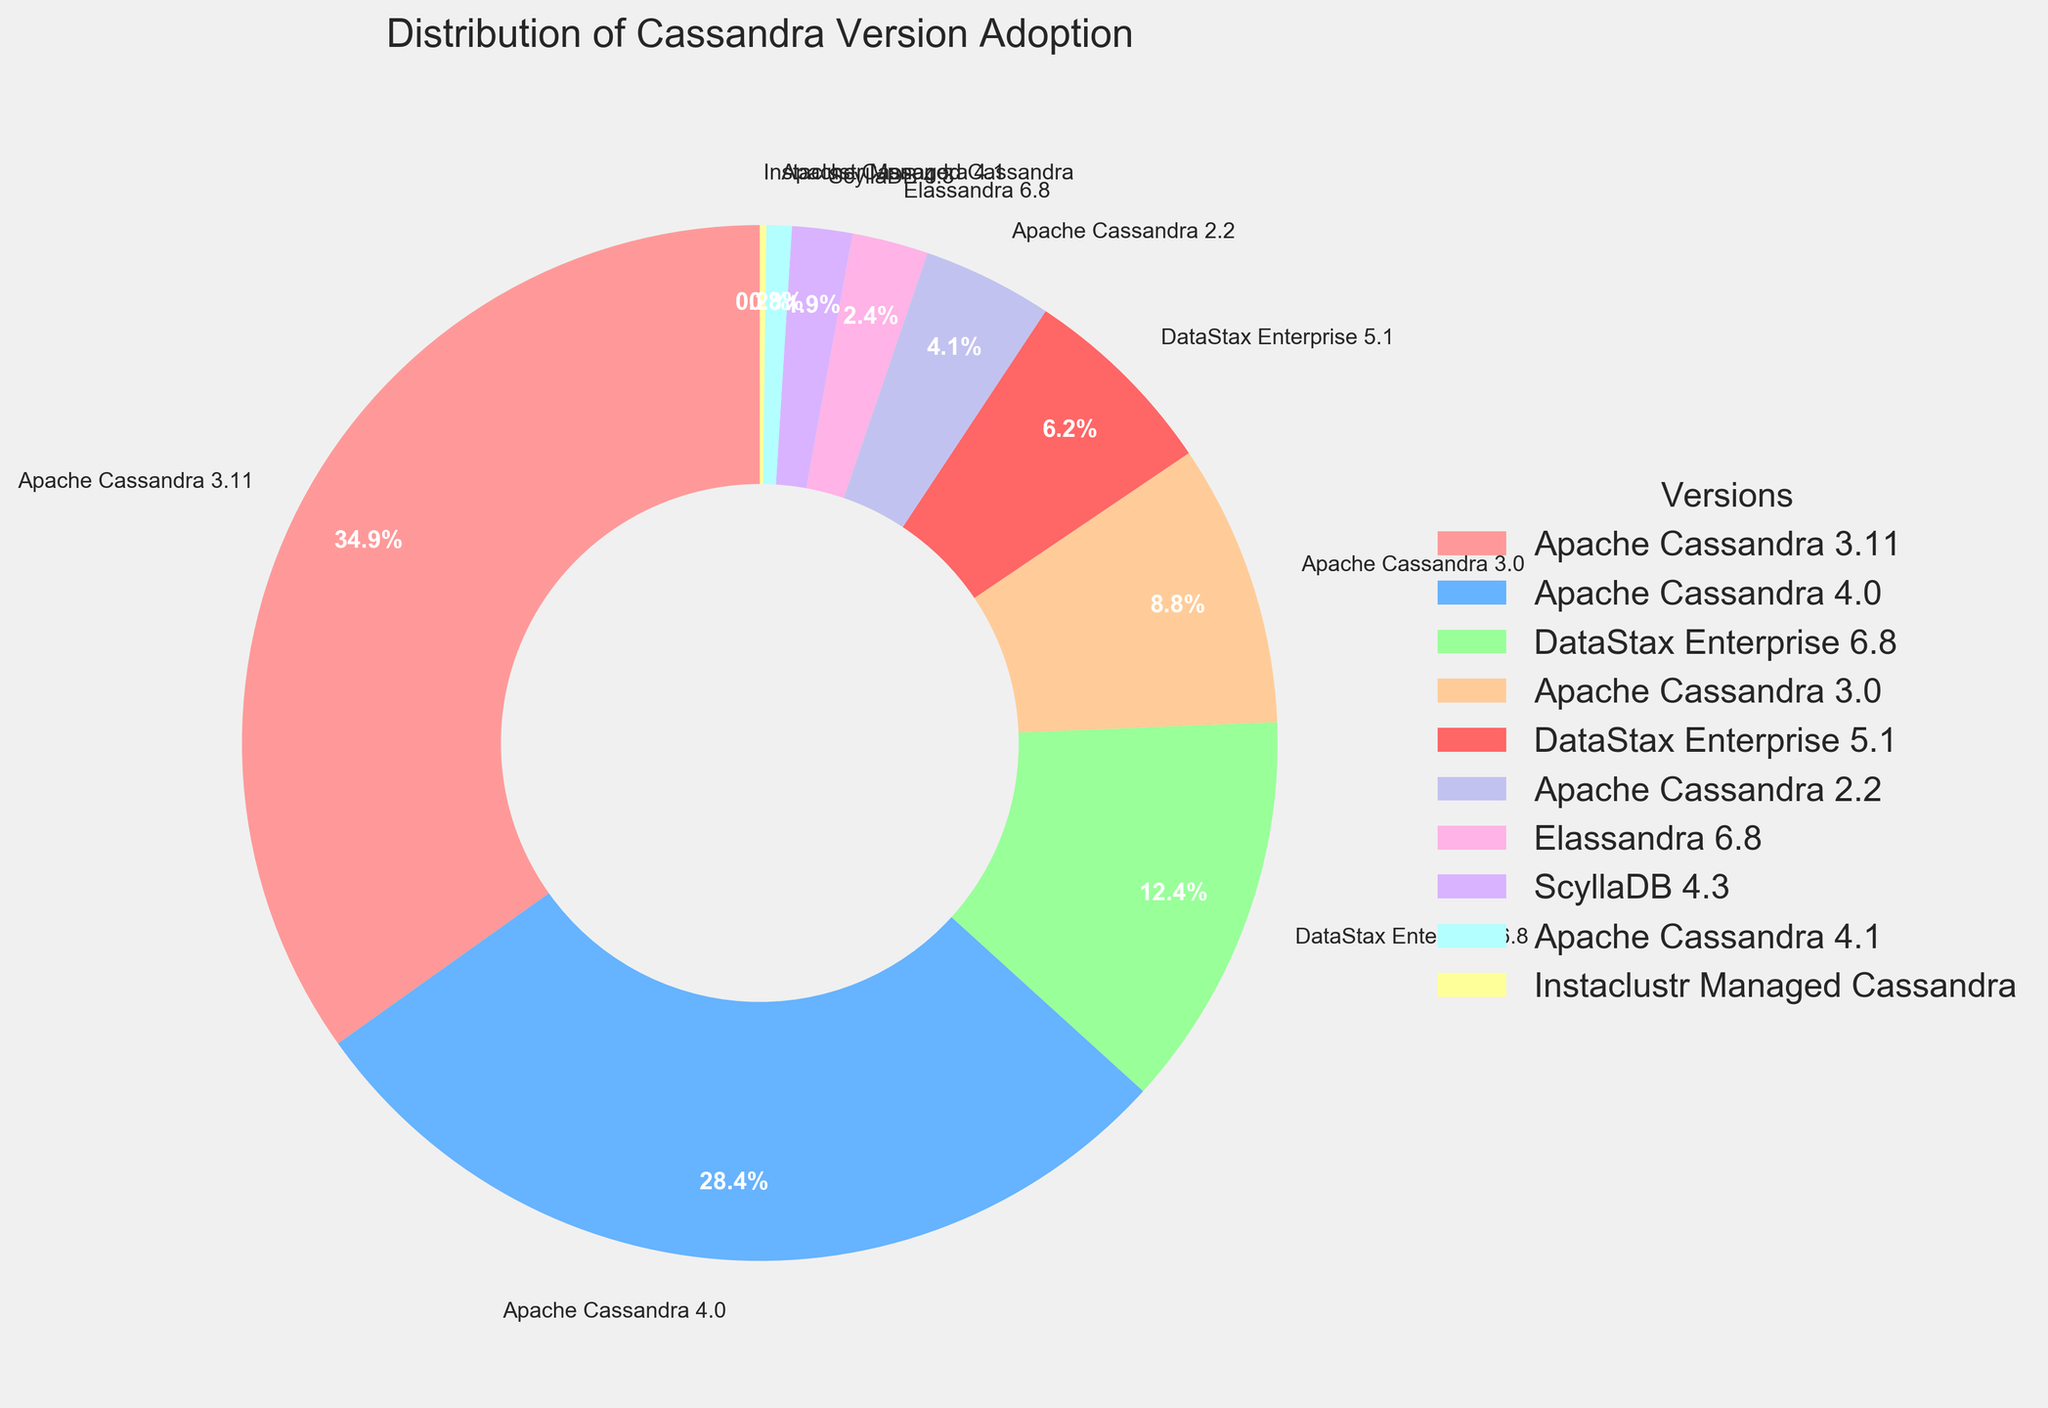What is the most adopted Cassandra version among organizations? The most adopted version can be identified by finding the version with the highest percentage. Apache Cassandra 3.11 has the highest percentage at 35.2%.
Answer: Apache Cassandra 3.11 Which version has a higher adoption rate: Apache Cassandra 4.0 or DataStax Enterprise 6.8? Compare the percentages of the two versions. Apache Cassandra 4.0 has 28.7%, and DataStax Enterprise 6.8 has 12.5%. Apache Cassandra 4.0 has a higher adoption rate.
Answer: Apache Cassandra 4.0 What is the combined adoption percentage of all Apache Cassandra versions? Sum the percentages of all Apache Cassandra versions: 35.2% (3.11) + 28.7% (4.0) + 8.9% (3.0) + 4.1% (2.2) + 0.8% (4.1) = 77.7%.
Answer: 77.7% Rank the top three Cassandra versions by adoption percentage. To rank the top three, we list the versions in order of their adoption percentages: 35.2% (Apache Cassandra 3.11), 28.7% (Apache Cassandra 4.0), 12.5% (DataStax Enterprise 6.8).
Answer: 1. Apache Cassandra 3.11, 2. Apache Cassandra 4.0, 3. DataStax Enterprise 6.8 How much more popular is Apache Cassandra 3.11 compared to Apache Cassandra 3.0? Subtract the percentage of Apache Cassandra 3.0 from Apache Cassandra 3.11: 35.2% - 8.9% = 26.3%.
Answer: 26.3% What is the least adopted version? Identify the version with the lowest percentage. Instaclustr Managed Cassandra has the lowest percentage at 0.2%.
Answer: Instaclustr Managed Cassandra If an organization uses only versions with over 10% adoption, which versions could they be using? Identify all versions with percentages over 10%: Apache Cassandra 3.11 (35.2%), Apache Cassandra 4.0 (28.7%), DataStax Enterprise 6.8 (12.5%).
Answer: Apache Cassandra 3.11, Apache Cassandra 4.0, DataStax Enterprise 6.8 Which version within the DataStax Enterprise distribution has a higher adoption rate? Compare the percentages of the DataStax Enterprise versions: DSE 6.8 has 12.5% and DSE 5.1 has 6.3%. DSE 6.8 has the higher adoption rate.
Answer: DataStax Enterprise 6.8 How does the adoption rate of Elassandra compare to ScyllaDB 4.3? Compare the percentages of Elassandra and ScyllaDB: Elassandra has 2.4% and ScyllaDB has 1.9%. Elassandra has a higher adoption rate.
Answer: Elassandra 